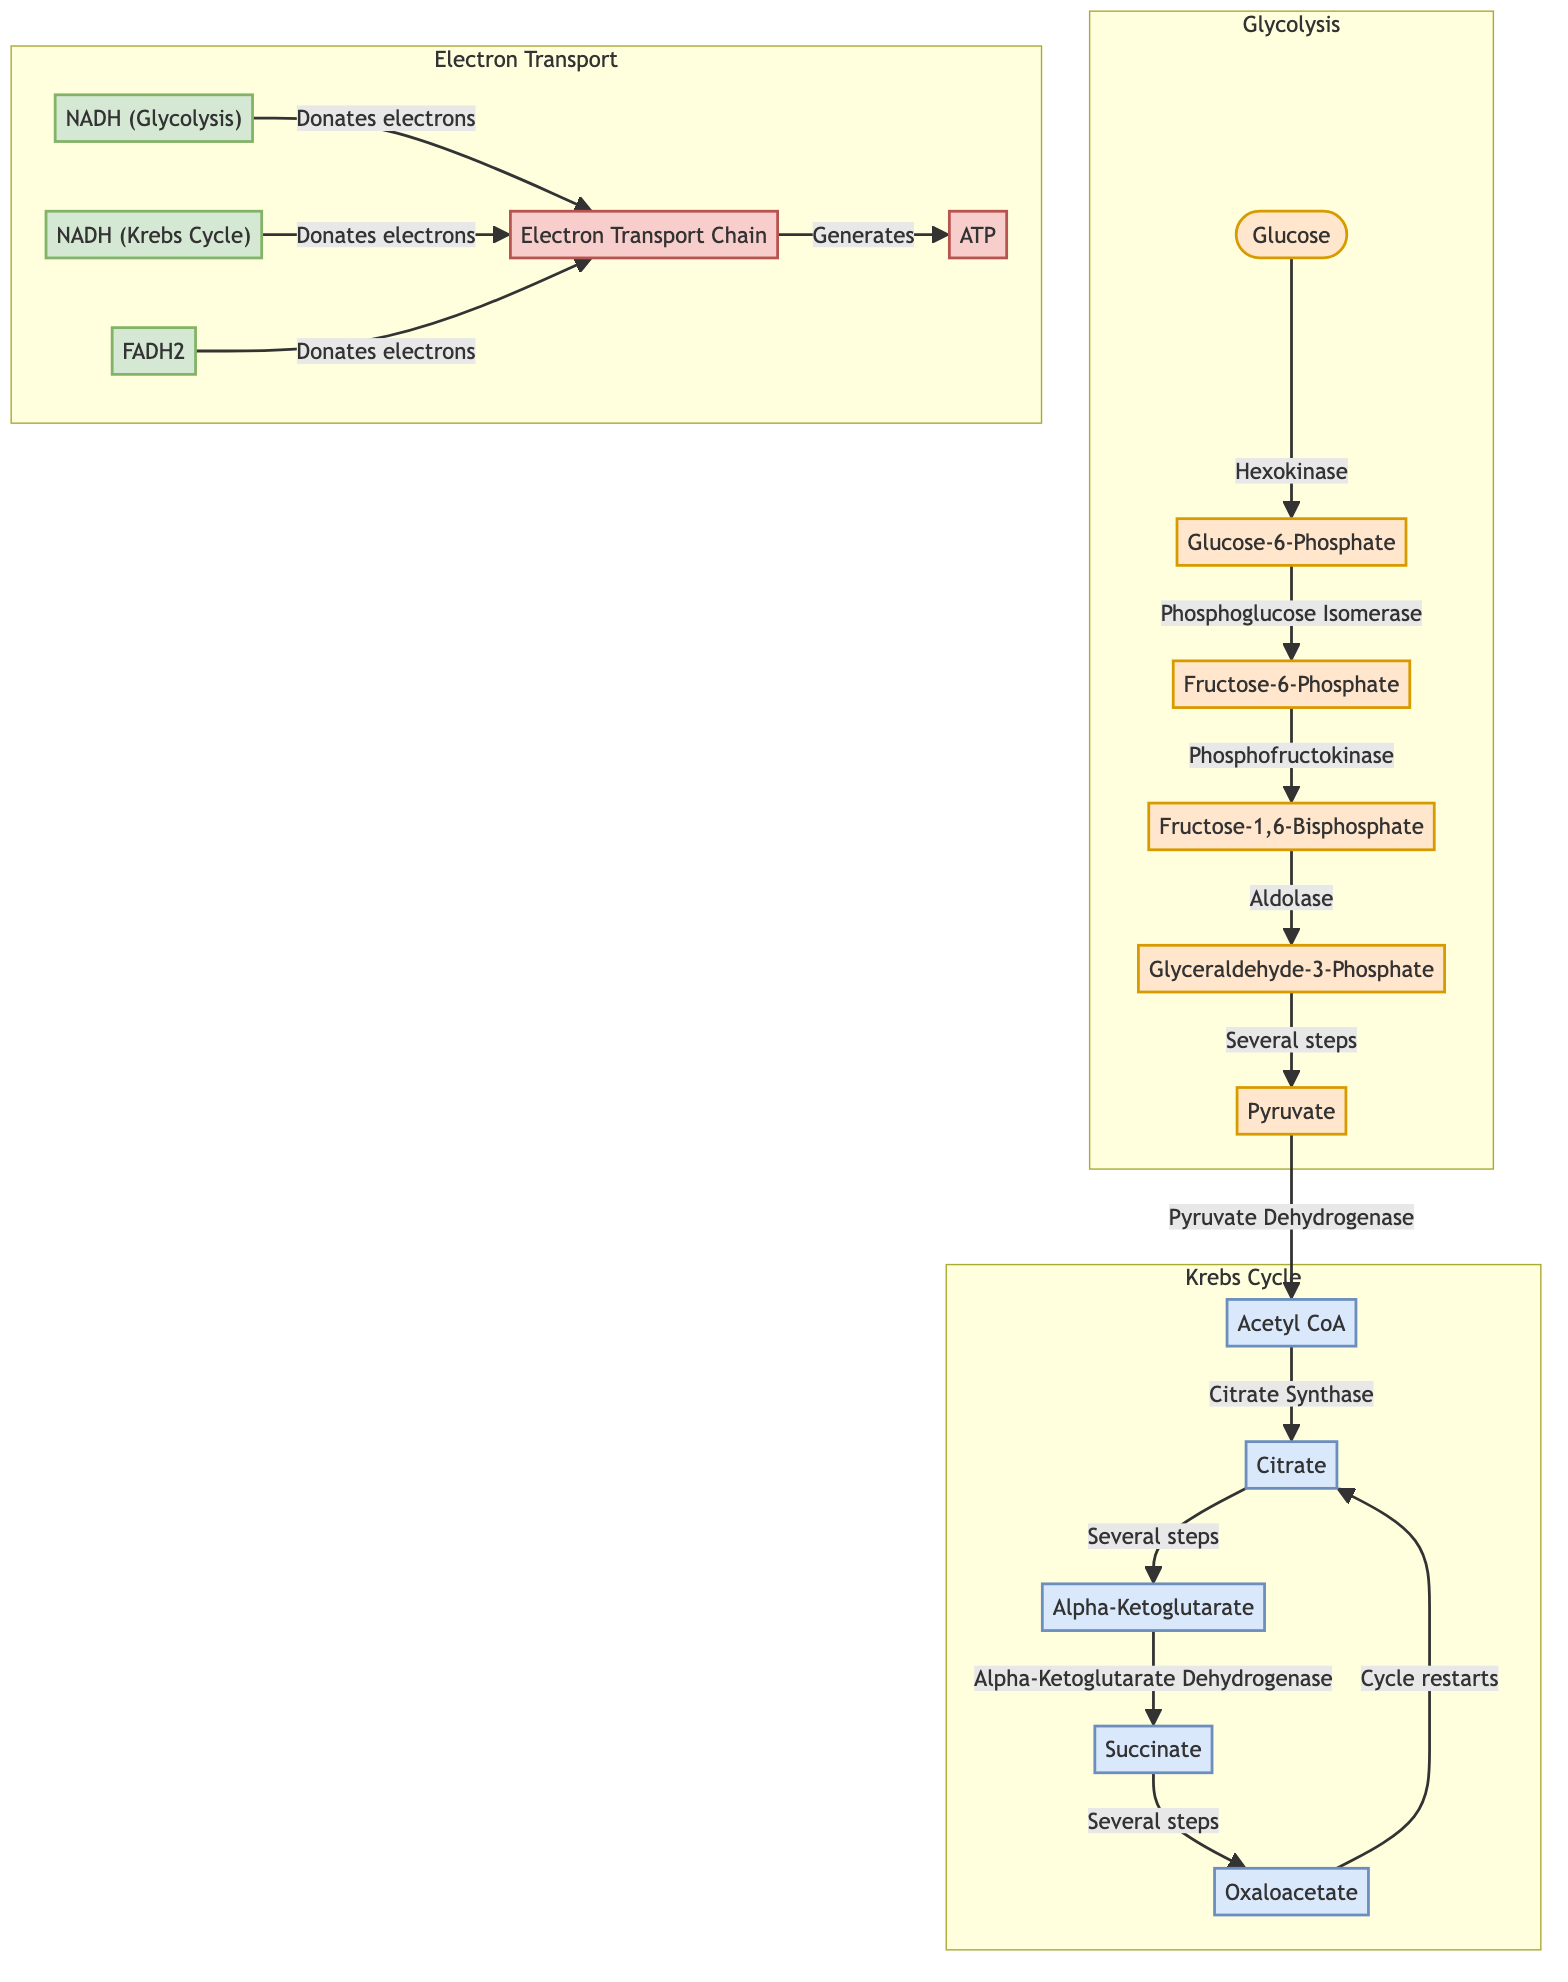What is the first molecule in the Glycolysis pathway? The diagram starts with the node labeled "Glucose," which is the first molecule in the Glycolysis pathway.
Answer: Glucose How many steps are there in the Krebs Cycle shown in the diagram? The Krebs Cycle consists of five distinct nodes (Acetyl CoA, Citrate, Alpha-Ketoglutarate, Succinate, and Oxaloacetate), indicating the major steps in this cycle.
Answer: Five What type of enzyme converts Fructose-6-Phosphate to Fructose-1,6-Bisphosphate? According to the diagram, the arrow connecting Fructose-6-Phosphate to Fructose-1,6-Bisphosphate is labeled "Phosphofructokinase," which indicates the type of enzyme responsible for this conversion.
Answer: Phosphofructokinase Which molecule donates electrons to the Electron Transport Chain from Glycolysis? The diagram shows that "NADH (Glycolysis)" is connected by an arrow labeled "Donates electrons" to the Electron Transport Chain (ETC), indicating that this molecule donates electrons.
Answer: NADH (Glycolysis) What regenerates Oxaloacetate in the Krebs Cycle? The flow of the Krebs Cycle indicates that "Succinate" converts back to "Oxaloacetate" through several steps, thus regenerating Oxaloacetate and allowing the cycle to continue.
Answer: Succinate How many total electron donors are indicated in the diagram? A quick count reveals three electron donors: "NADH (Glycolysis)," "NADH (Krebs Cycle)," and "FADH2." Therefore, the total number of electron donors is three.
Answer: Three What is the end product of the Electron Transport Chain? The diagram shows that the Electron Transport Chain connects to the node labeled "ATP," indicating that ATP is the end product generated from this process.
Answer: ATP Which cycle restarts after producing Oxaloacetate? The arrow in the diagram indicates that after "Oxaloacetate" is formed, it leads back to "Citrate," signaling that the Krebs Cycle is the one that restarts after the production of Oxaloacetate.
Answer: Krebs Cycle What is the relationship between Pyruvate and Acetyl CoA? The diagram shows an arrow labeled "Pyruvate Dehydrogenase" connecting "Pyruvate" to "Acetyl CoA," indicating that this enzyme facilitates the conversion of Pyruvate to Acetyl CoA.
Answer: Pyruvate Dehydrogenase 